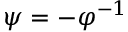<formula> <loc_0><loc_0><loc_500><loc_500>\psi = - \varphi ^ { - 1 }</formula> 